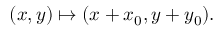<formula> <loc_0><loc_0><loc_500><loc_500>( x , y ) \mapsto ( x + x _ { 0 } , y + y _ { 0 } ) .</formula> 